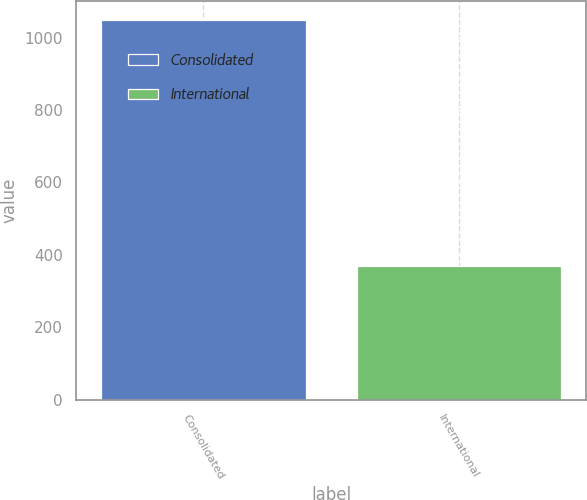Convert chart to OTSL. <chart><loc_0><loc_0><loc_500><loc_500><bar_chart><fcel>Consolidated<fcel>International<nl><fcel>1048.5<fcel>369.3<nl></chart> 